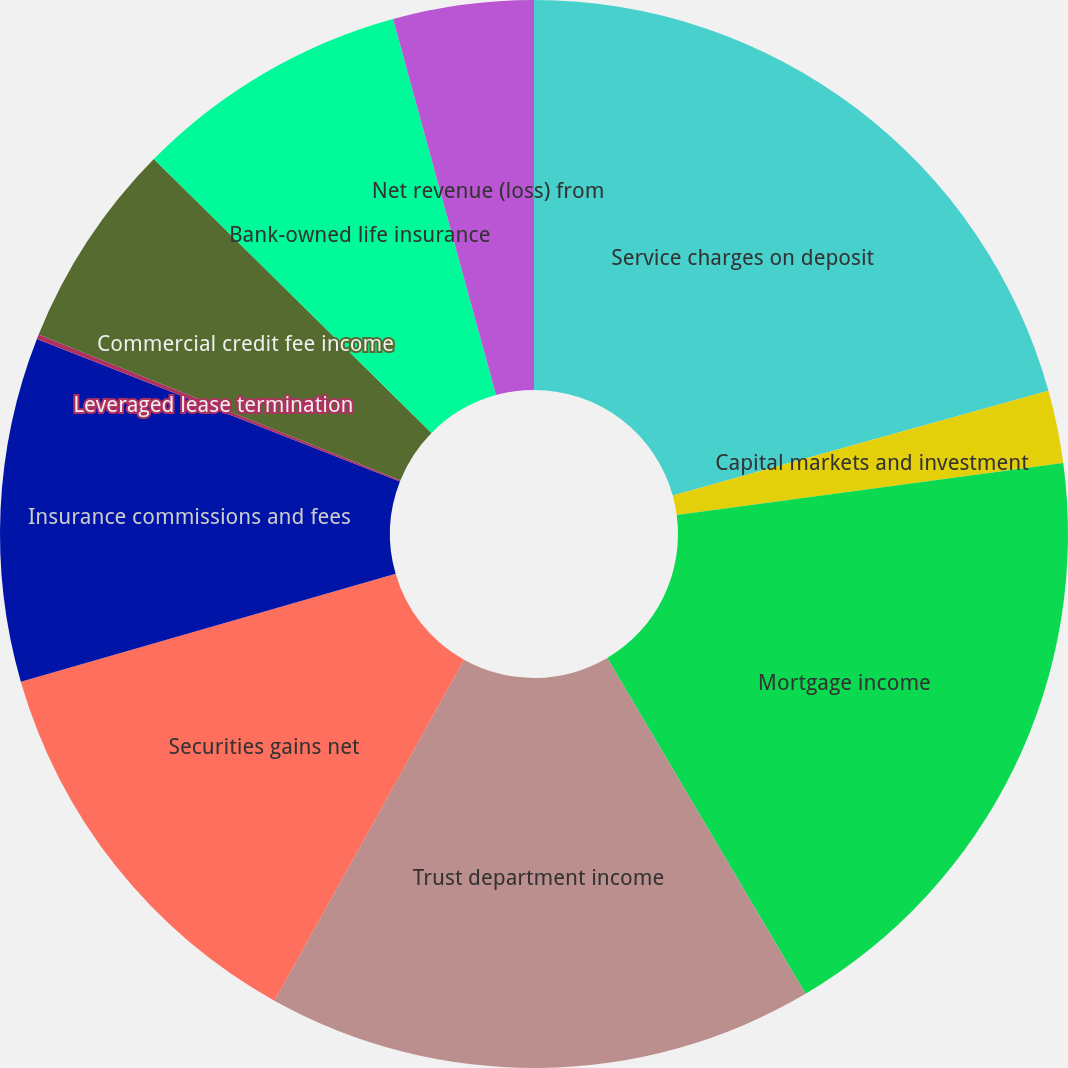Convert chart to OTSL. <chart><loc_0><loc_0><loc_500><loc_500><pie_chart><fcel>Service charges on deposit<fcel>Capital markets and investment<fcel>Mortgage income<fcel>Trust department income<fcel>Securities gains net<fcel>Insurance commissions and fees<fcel>Leveraged lease termination<fcel>Commercial credit fee income<fcel>Bank-owned life insurance<fcel>Net revenue (loss) from<nl><fcel>20.68%<fcel>2.2%<fcel>18.63%<fcel>16.57%<fcel>12.46%<fcel>10.41%<fcel>0.14%<fcel>6.3%<fcel>8.36%<fcel>4.25%<nl></chart> 